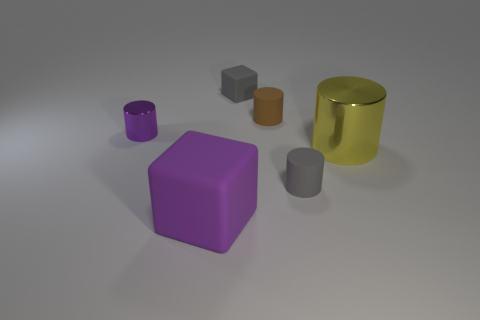What material is the small cylinder that is the same color as the tiny block?
Your answer should be compact. Rubber. Are there any brown objects that have the same size as the yellow cylinder?
Your response must be concise. No. What number of objects are either tiny matte cylinders that are behind the big yellow thing or large things in front of the large metal thing?
Ensure brevity in your answer.  2. There is another thing that is the same size as the yellow object; what shape is it?
Ensure brevity in your answer.  Cube. Is there a big yellow metallic object that has the same shape as the large purple object?
Ensure brevity in your answer.  No. Are there fewer small metal cylinders than brown metal blocks?
Your answer should be compact. No. Is the size of the shiny cylinder that is to the right of the large purple object the same as the matte cube behind the tiny metal thing?
Provide a short and direct response. No. What number of things are either tiny gray cylinders or small rubber blocks?
Make the answer very short. 2. There is a metallic thing to the left of the big purple block; what is its size?
Ensure brevity in your answer.  Small. There is a shiny thing that is on the left side of the tiny rubber cylinder that is in front of the purple metal object; how many matte cubes are behind it?
Make the answer very short. 1. 